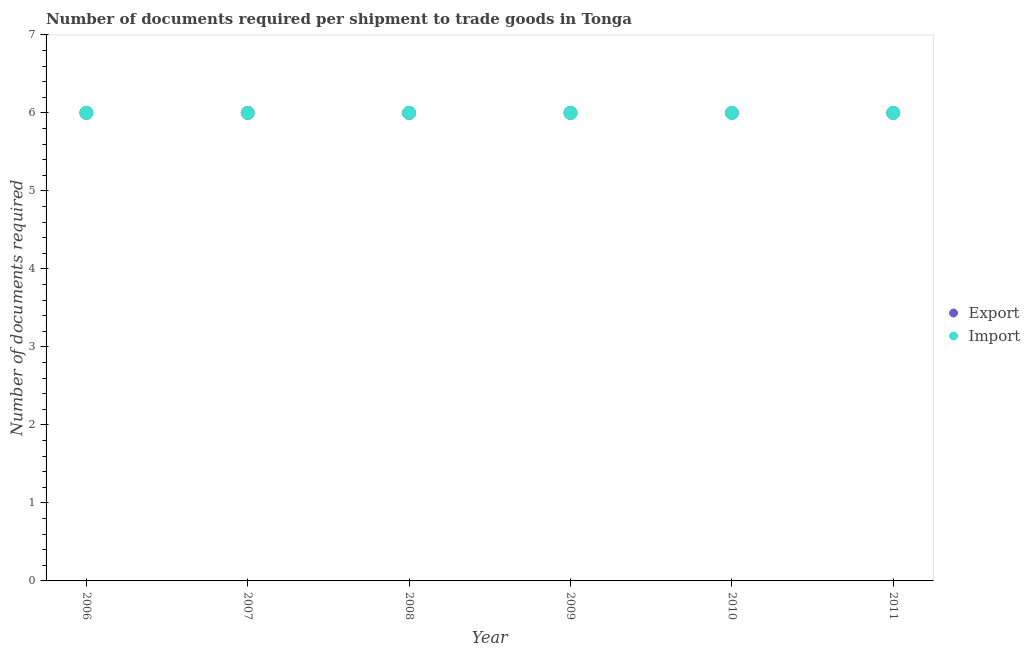How many different coloured dotlines are there?
Your answer should be very brief. 2. Is the number of dotlines equal to the number of legend labels?
Offer a very short reply. Yes. What is the number of documents required to export goods in 2007?
Provide a succinct answer. 6. In which year was the number of documents required to export goods minimum?
Offer a very short reply. 2006. What is the total number of documents required to import goods in the graph?
Offer a terse response. 36. What is the average number of documents required to export goods per year?
Ensure brevity in your answer.  6. In the year 2010, what is the difference between the number of documents required to import goods and number of documents required to export goods?
Ensure brevity in your answer.  0. What is the difference between the highest and the second highest number of documents required to import goods?
Keep it short and to the point. 0. In how many years, is the number of documents required to export goods greater than the average number of documents required to export goods taken over all years?
Ensure brevity in your answer.  0. How many dotlines are there?
Ensure brevity in your answer.  2. Does the graph contain grids?
Your answer should be very brief. No. How are the legend labels stacked?
Provide a short and direct response. Vertical. What is the title of the graph?
Provide a succinct answer. Number of documents required per shipment to trade goods in Tonga. What is the label or title of the X-axis?
Keep it short and to the point. Year. What is the label or title of the Y-axis?
Provide a short and direct response. Number of documents required. What is the Number of documents required of Export in 2007?
Give a very brief answer. 6. What is the Number of documents required in Import in 2007?
Ensure brevity in your answer.  6. What is the Number of documents required of Export in 2008?
Your answer should be very brief. 6. What is the Number of documents required in Import in 2008?
Make the answer very short. 6. What is the Number of documents required in Export in 2009?
Your response must be concise. 6. What is the Number of documents required of Import in 2009?
Your response must be concise. 6. What is the Number of documents required of Export in 2010?
Offer a terse response. 6. What is the Number of documents required in Export in 2011?
Your answer should be compact. 6. What is the Number of documents required of Import in 2011?
Your answer should be very brief. 6. Across all years, what is the maximum Number of documents required of Import?
Your answer should be very brief. 6. What is the total Number of documents required in Export in the graph?
Your answer should be very brief. 36. What is the difference between the Number of documents required in Import in 2006 and that in 2008?
Offer a very short reply. 0. What is the difference between the Number of documents required of Export in 2006 and that in 2011?
Your answer should be very brief. 0. What is the difference between the Number of documents required in Import in 2007 and that in 2008?
Keep it short and to the point. 0. What is the difference between the Number of documents required in Export in 2007 and that in 2010?
Provide a succinct answer. 0. What is the difference between the Number of documents required of Export in 2007 and that in 2011?
Offer a very short reply. 0. What is the difference between the Number of documents required in Import in 2008 and that in 2009?
Your answer should be compact. 0. What is the difference between the Number of documents required of Export in 2008 and that in 2010?
Give a very brief answer. 0. What is the difference between the Number of documents required in Export in 2009 and that in 2010?
Ensure brevity in your answer.  0. What is the difference between the Number of documents required in Import in 2009 and that in 2011?
Ensure brevity in your answer.  0. What is the difference between the Number of documents required in Import in 2010 and that in 2011?
Your answer should be very brief. 0. What is the difference between the Number of documents required of Export in 2006 and the Number of documents required of Import in 2008?
Make the answer very short. 0. What is the difference between the Number of documents required in Export in 2006 and the Number of documents required in Import in 2009?
Offer a very short reply. 0. What is the difference between the Number of documents required of Export in 2006 and the Number of documents required of Import in 2010?
Provide a short and direct response. 0. What is the difference between the Number of documents required in Export in 2006 and the Number of documents required in Import in 2011?
Make the answer very short. 0. What is the difference between the Number of documents required of Export in 2007 and the Number of documents required of Import in 2010?
Keep it short and to the point. 0. What is the difference between the Number of documents required of Export in 2008 and the Number of documents required of Import in 2010?
Make the answer very short. 0. What is the difference between the Number of documents required in Export in 2009 and the Number of documents required in Import in 2010?
Offer a terse response. 0. What is the average Number of documents required in Export per year?
Keep it short and to the point. 6. In the year 2008, what is the difference between the Number of documents required of Export and Number of documents required of Import?
Make the answer very short. 0. In the year 2009, what is the difference between the Number of documents required in Export and Number of documents required in Import?
Provide a succinct answer. 0. In the year 2010, what is the difference between the Number of documents required of Export and Number of documents required of Import?
Offer a terse response. 0. In the year 2011, what is the difference between the Number of documents required of Export and Number of documents required of Import?
Your answer should be very brief. 0. What is the ratio of the Number of documents required in Import in 2006 to that in 2007?
Keep it short and to the point. 1. What is the ratio of the Number of documents required of Export in 2006 to that in 2008?
Your answer should be compact. 1. What is the ratio of the Number of documents required of Import in 2006 to that in 2008?
Keep it short and to the point. 1. What is the ratio of the Number of documents required in Export in 2006 to that in 2009?
Offer a terse response. 1. What is the ratio of the Number of documents required of Import in 2006 to that in 2009?
Ensure brevity in your answer.  1. What is the ratio of the Number of documents required of Export in 2006 to that in 2011?
Ensure brevity in your answer.  1. What is the ratio of the Number of documents required of Import in 2006 to that in 2011?
Make the answer very short. 1. What is the ratio of the Number of documents required in Export in 2007 to that in 2008?
Provide a short and direct response. 1. What is the ratio of the Number of documents required of Export in 2007 to that in 2011?
Provide a short and direct response. 1. What is the ratio of the Number of documents required of Export in 2008 to that in 2009?
Make the answer very short. 1. What is the ratio of the Number of documents required in Export in 2008 to that in 2010?
Provide a short and direct response. 1. What is the ratio of the Number of documents required of Import in 2009 to that in 2010?
Ensure brevity in your answer.  1. What is the ratio of the Number of documents required in Import in 2009 to that in 2011?
Ensure brevity in your answer.  1. What is the ratio of the Number of documents required in Export in 2010 to that in 2011?
Make the answer very short. 1. What is the ratio of the Number of documents required in Import in 2010 to that in 2011?
Offer a terse response. 1. What is the difference between the highest and the second highest Number of documents required of Export?
Your answer should be very brief. 0. What is the difference between the highest and the lowest Number of documents required of Export?
Ensure brevity in your answer.  0. 